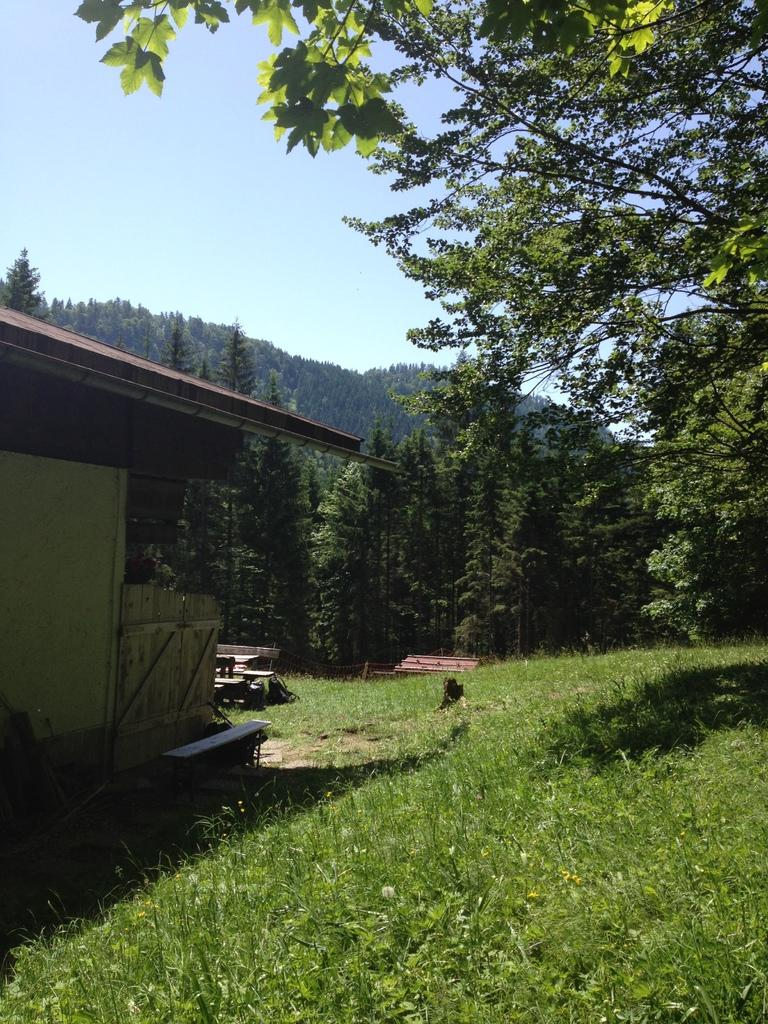What type of structure is present in the image? There is a house with a roof in the image. What type of vegetation can be seen in the image? There is grass visible in the image. What type of seating is present in the image? There is a bench in the image. What type of natural elements are present in the image? There are trees in the image. What is visible in the sky in the image? The sky is visible in the image and appears cloudy. What type of produce is being harvested by the father in the image? There is no father or produce present in the image. 